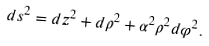Convert formula to latex. <formula><loc_0><loc_0><loc_500><loc_500>d s ^ { 2 } = d z ^ { 2 } + d \rho ^ { 2 } + \alpha ^ { 2 } \rho ^ { 2 } d \varphi ^ { 2 } .</formula> 